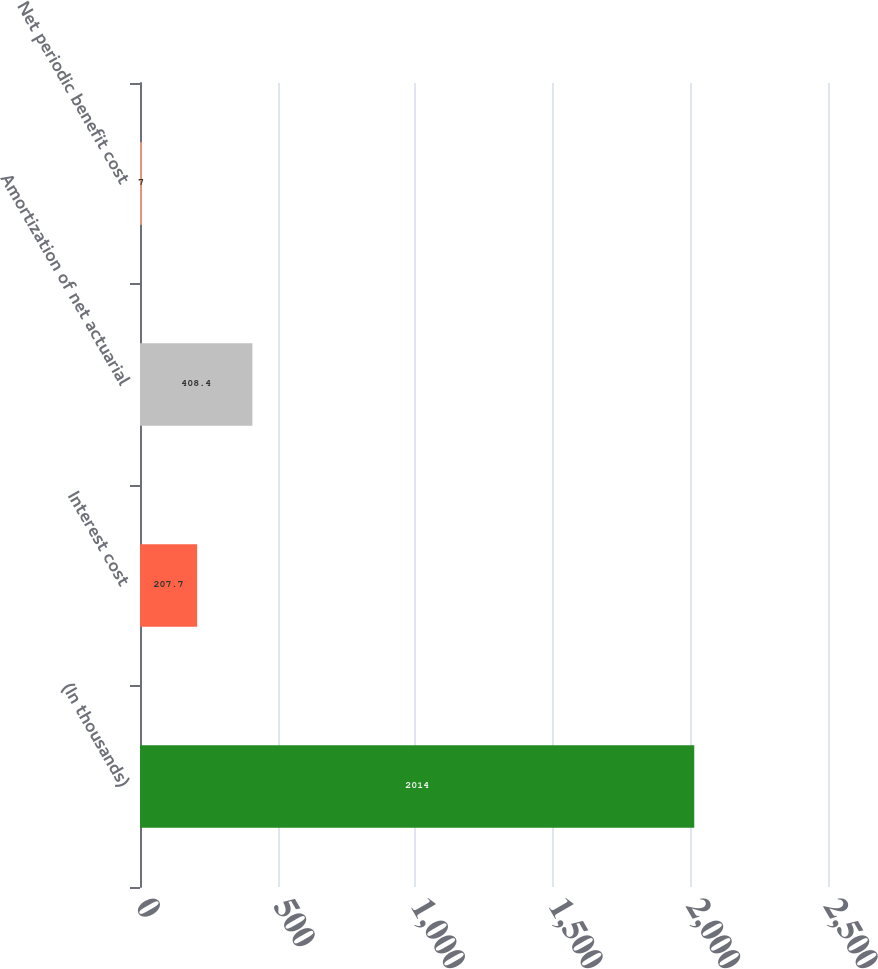Convert chart. <chart><loc_0><loc_0><loc_500><loc_500><bar_chart><fcel>(In thousands)<fcel>Interest cost<fcel>Amortization of net actuarial<fcel>Net periodic benefit cost<nl><fcel>2014<fcel>207.7<fcel>408.4<fcel>7<nl></chart> 